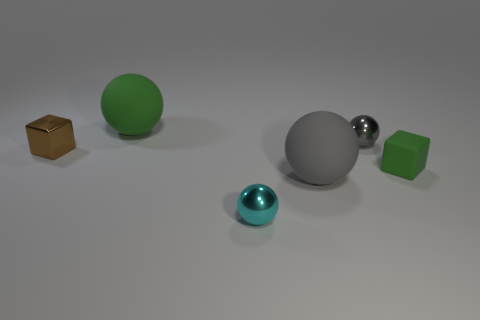What shape is the rubber thing that is the same size as the green matte sphere?
Make the answer very short. Sphere. How many large gray matte balls are behind the large matte ball that is in front of the tiny thing that is right of the gray metallic ball?
Provide a short and direct response. 0. Is the number of small shiny balls that are to the right of the small green matte cube greater than the number of big green rubber spheres on the left side of the green rubber sphere?
Your answer should be compact. No. How many shiny things have the same shape as the big gray matte object?
Offer a terse response. 2. How many objects are objects behind the cyan ball or tiny spheres in front of the gray shiny sphere?
Offer a very short reply. 6. What material is the cube on the left side of the large rubber object behind the object to the right of the gray metal object made of?
Keep it short and to the point. Metal. There is a rubber object on the left side of the tiny cyan ball; is it the same color as the small shiny block?
Give a very brief answer. No. What material is the small thing that is both behind the small green object and in front of the tiny gray ball?
Give a very brief answer. Metal. Is there a red rubber cylinder that has the same size as the gray matte ball?
Provide a succinct answer. No. What number of small yellow cubes are there?
Ensure brevity in your answer.  0. 